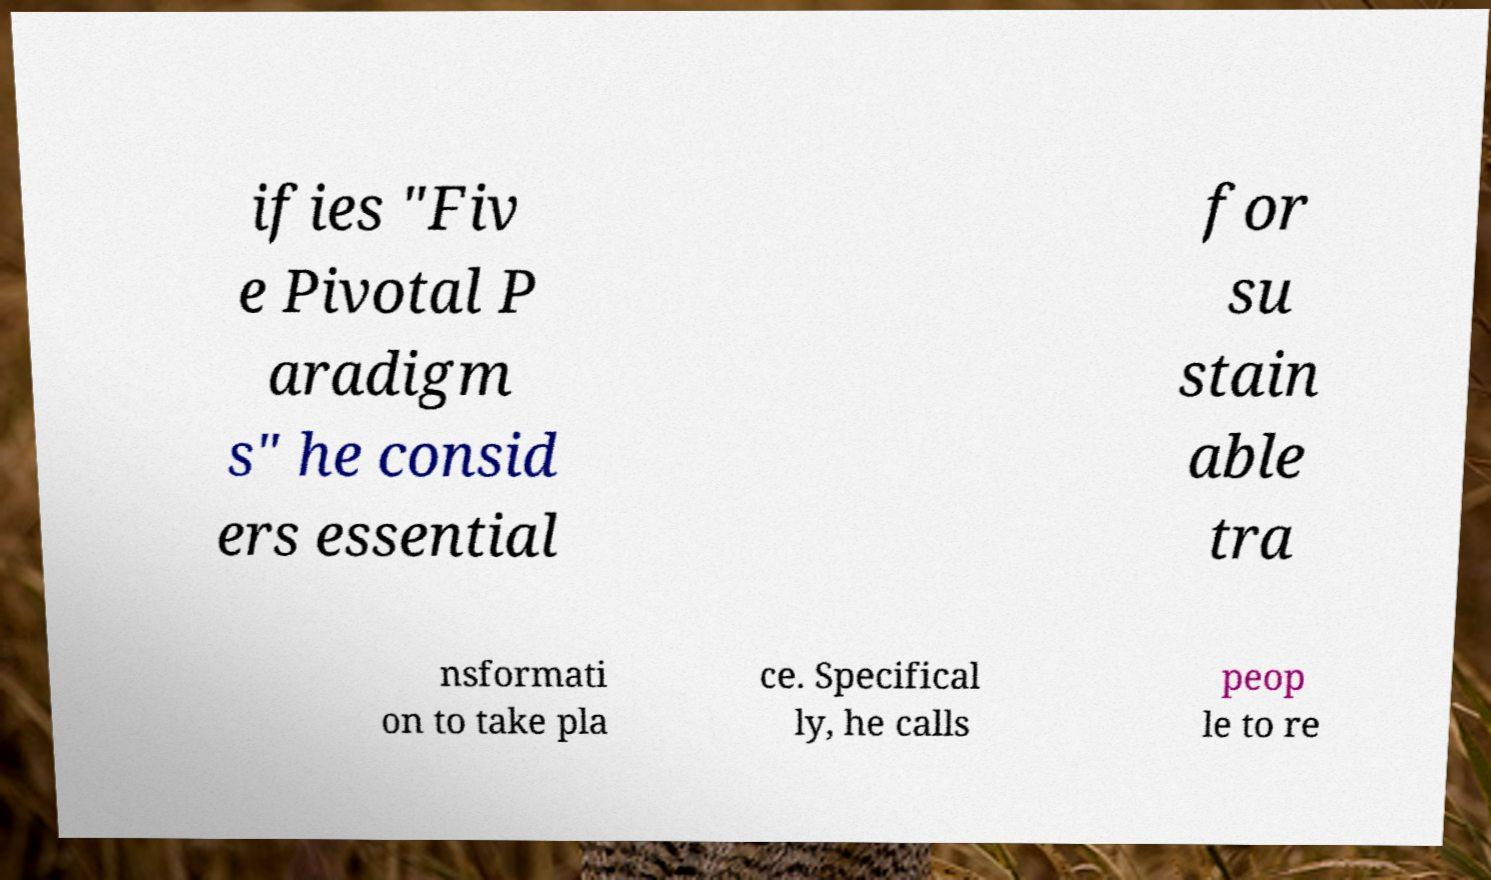Please identify and transcribe the text found in this image. ifies "Fiv e Pivotal P aradigm s" he consid ers essential for su stain able tra nsformati on to take pla ce. Specifical ly, he calls peop le to re 